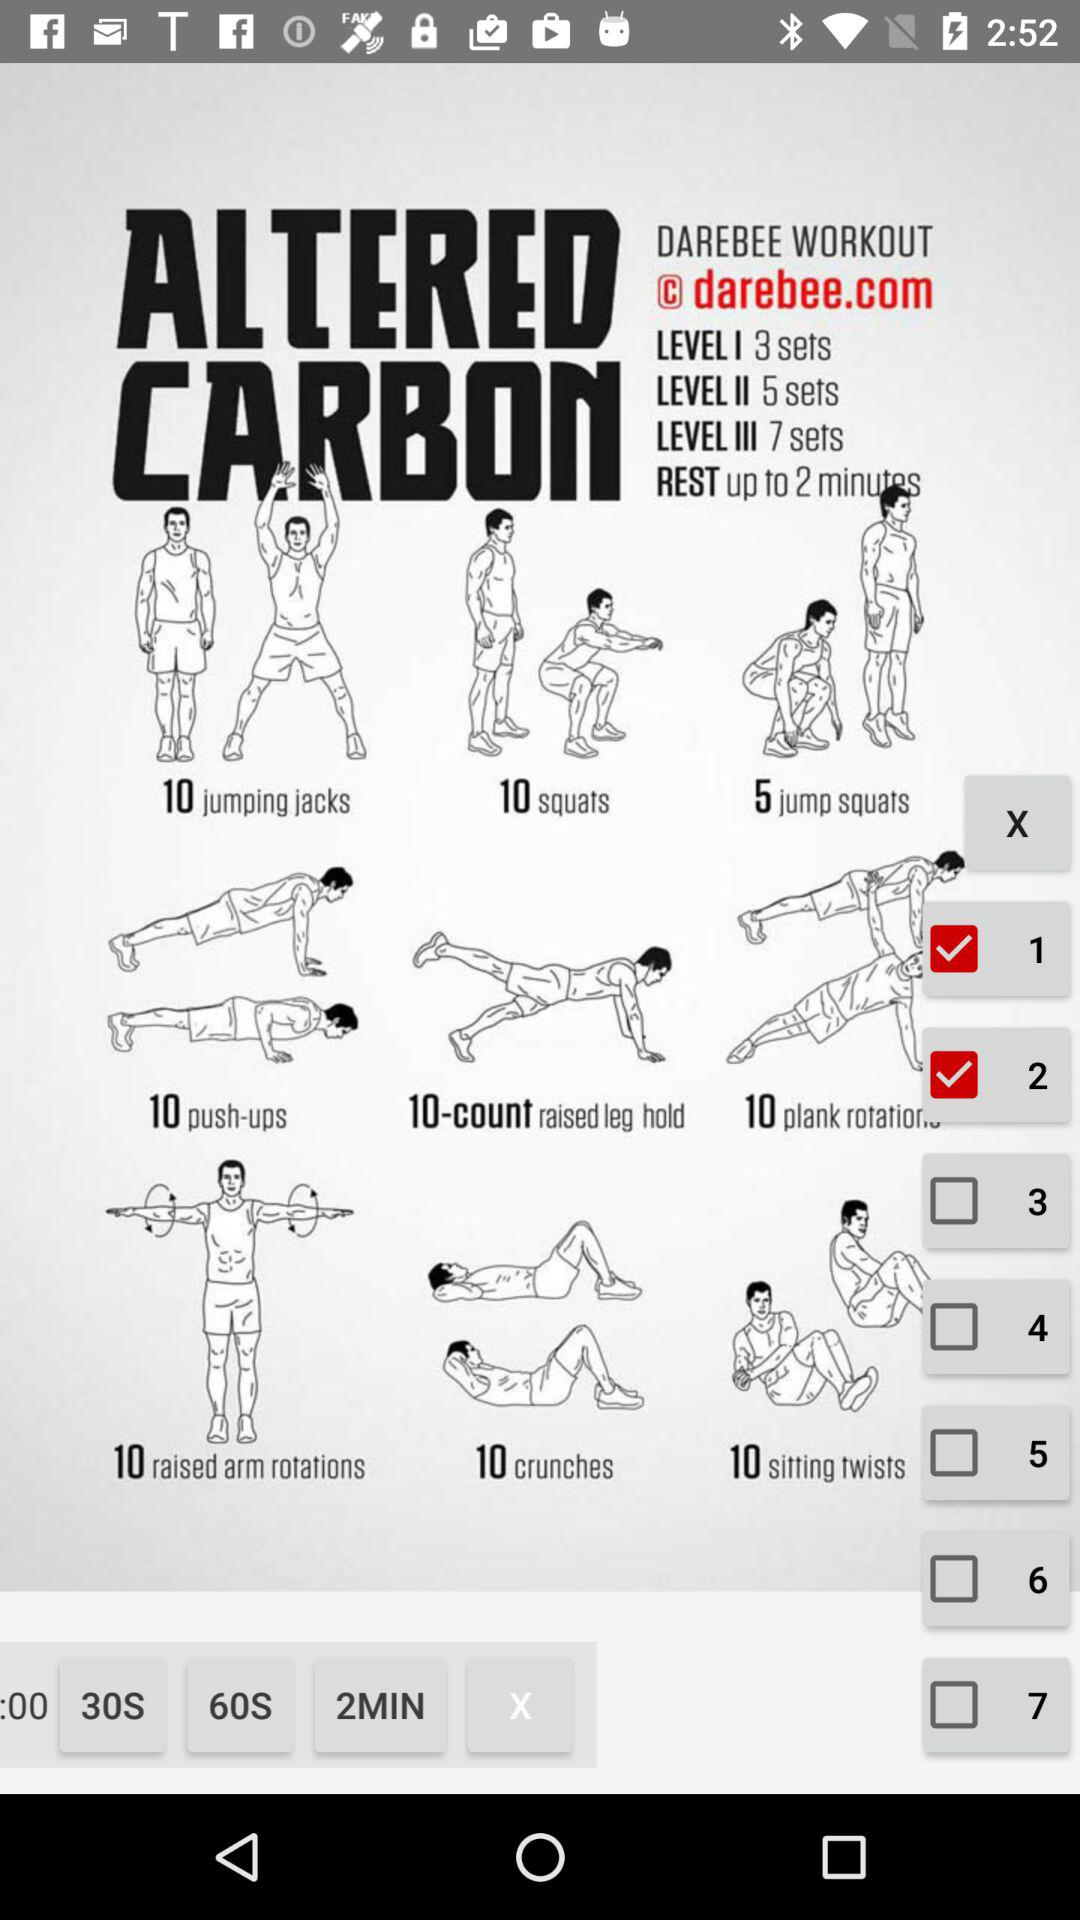What is the number of sets in level three? The number of sets in level three is 7. 